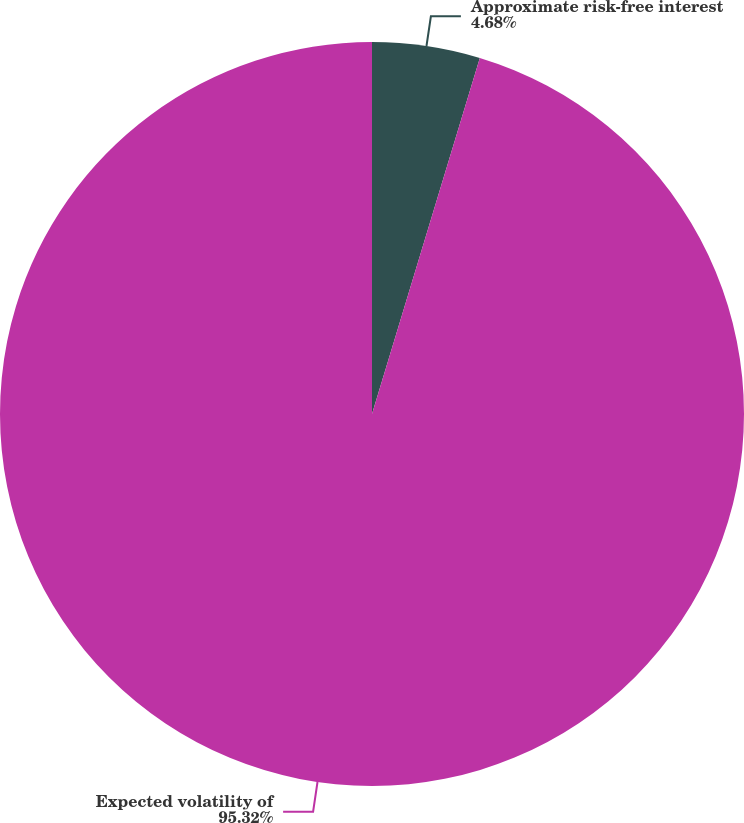Convert chart to OTSL. <chart><loc_0><loc_0><loc_500><loc_500><pie_chart><fcel>Approximate risk-free interest<fcel>Expected volatility of<nl><fcel>4.68%<fcel>95.32%<nl></chart> 